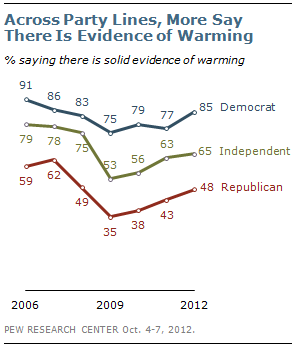Outline some significant characteristics in this image. In 2012, there was a significant difference in the percentage of Democrats and Republicans who believed there was solid evidence of warming, with 37% of Democrats and only 20% of Republicans expressing this view. There is strong evidence of warming among Democrats in 2012, with 85% of the data supporting this conclusion. 